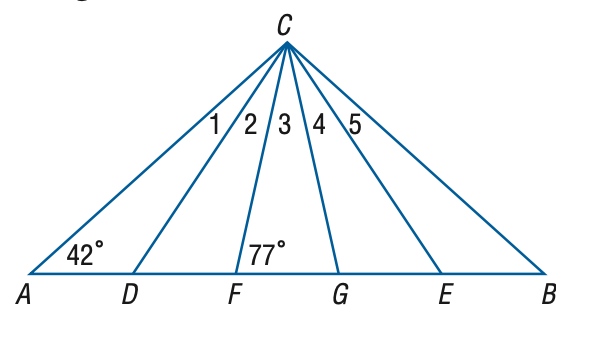Question: In the figure, \triangle A B C is isosceles, \triangle D C E is equilateral, and \triangle F C G is isosceles. Find the measure of the \angle 3 at vertex C.
Choices:
A. 22
B. 26
C. 27
D. 28
Answer with the letter. Answer: B Question: In the figure, \triangle A B C is isosceles, \triangle D C E is equilateral, and \triangle F C G is isosceles. Find the measure of the \angle 2 at vertex C.
Choices:
A. 14
B. 16
C. 17
D. 18
Answer with the letter. Answer: C Question: In the figure, \triangle A B C is isosceles, \triangle D C E is equilateral, and \triangle F C G is isosceles. Find the measure of the \angle 5 at vertex C.
Choices:
A. 15
B. 16
C. 17
D. 18
Answer with the letter. Answer: D Question: In the figure, \triangle A B C is isosceles, \triangle D C E is equilateral, and \triangle F C G is isosceles. Find the measure of the \angle 4 at vertex C.
Choices:
A. 15
B. 16
C. 17
D. 18
Answer with the letter. Answer: C 